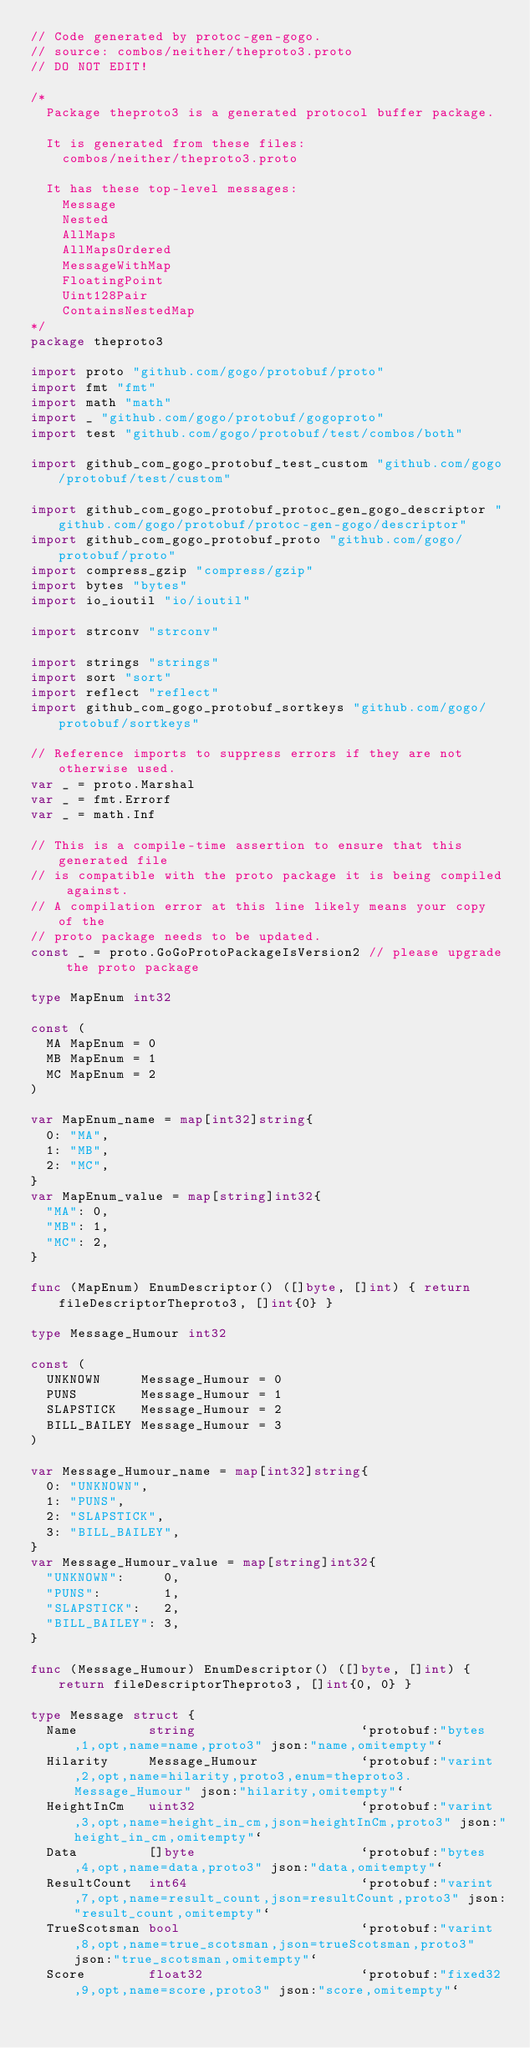Convert code to text. <code><loc_0><loc_0><loc_500><loc_500><_Go_>// Code generated by protoc-gen-gogo.
// source: combos/neither/theproto3.proto
// DO NOT EDIT!

/*
	Package theproto3 is a generated protocol buffer package.

	It is generated from these files:
		combos/neither/theproto3.proto

	It has these top-level messages:
		Message
		Nested
		AllMaps
		AllMapsOrdered
		MessageWithMap
		FloatingPoint
		Uint128Pair
		ContainsNestedMap
*/
package theproto3

import proto "github.com/gogo/protobuf/proto"
import fmt "fmt"
import math "math"
import _ "github.com/gogo/protobuf/gogoproto"
import test "github.com/gogo/protobuf/test/combos/both"

import github_com_gogo_protobuf_test_custom "github.com/gogo/protobuf/test/custom"

import github_com_gogo_protobuf_protoc_gen_gogo_descriptor "github.com/gogo/protobuf/protoc-gen-gogo/descriptor"
import github_com_gogo_protobuf_proto "github.com/gogo/protobuf/proto"
import compress_gzip "compress/gzip"
import bytes "bytes"
import io_ioutil "io/ioutil"

import strconv "strconv"

import strings "strings"
import sort "sort"
import reflect "reflect"
import github_com_gogo_protobuf_sortkeys "github.com/gogo/protobuf/sortkeys"

// Reference imports to suppress errors if they are not otherwise used.
var _ = proto.Marshal
var _ = fmt.Errorf
var _ = math.Inf

// This is a compile-time assertion to ensure that this generated file
// is compatible with the proto package it is being compiled against.
// A compilation error at this line likely means your copy of the
// proto package needs to be updated.
const _ = proto.GoGoProtoPackageIsVersion2 // please upgrade the proto package

type MapEnum int32

const (
	MA MapEnum = 0
	MB MapEnum = 1
	MC MapEnum = 2
)

var MapEnum_name = map[int32]string{
	0: "MA",
	1: "MB",
	2: "MC",
}
var MapEnum_value = map[string]int32{
	"MA": 0,
	"MB": 1,
	"MC": 2,
}

func (MapEnum) EnumDescriptor() ([]byte, []int) { return fileDescriptorTheproto3, []int{0} }

type Message_Humour int32

const (
	UNKNOWN     Message_Humour = 0
	PUNS        Message_Humour = 1
	SLAPSTICK   Message_Humour = 2
	BILL_BAILEY Message_Humour = 3
)

var Message_Humour_name = map[int32]string{
	0: "UNKNOWN",
	1: "PUNS",
	2: "SLAPSTICK",
	3: "BILL_BAILEY",
}
var Message_Humour_value = map[string]int32{
	"UNKNOWN":     0,
	"PUNS":        1,
	"SLAPSTICK":   2,
	"BILL_BAILEY": 3,
}

func (Message_Humour) EnumDescriptor() ([]byte, []int) { return fileDescriptorTheproto3, []int{0, 0} }

type Message struct {
	Name         string                     `protobuf:"bytes,1,opt,name=name,proto3" json:"name,omitempty"`
	Hilarity     Message_Humour             `protobuf:"varint,2,opt,name=hilarity,proto3,enum=theproto3.Message_Humour" json:"hilarity,omitempty"`
	HeightInCm   uint32                     `protobuf:"varint,3,opt,name=height_in_cm,json=heightInCm,proto3" json:"height_in_cm,omitempty"`
	Data         []byte                     `protobuf:"bytes,4,opt,name=data,proto3" json:"data,omitempty"`
	ResultCount  int64                      `protobuf:"varint,7,opt,name=result_count,json=resultCount,proto3" json:"result_count,omitempty"`
	TrueScotsman bool                       `protobuf:"varint,8,opt,name=true_scotsman,json=trueScotsman,proto3" json:"true_scotsman,omitempty"`
	Score        float32                    `protobuf:"fixed32,9,opt,name=score,proto3" json:"score,omitempty"`</code> 